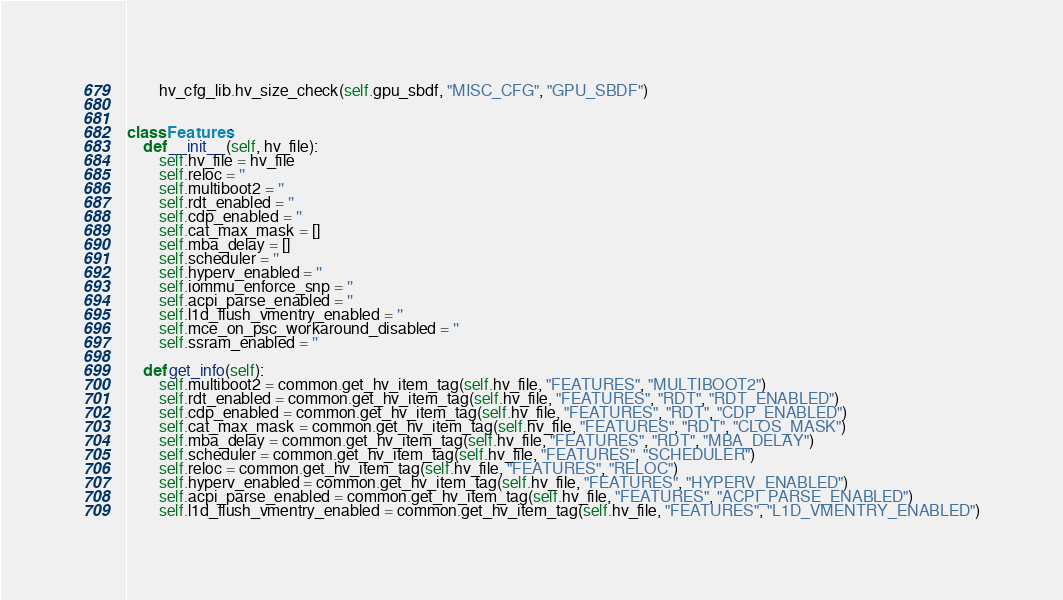Convert code to text. <code><loc_0><loc_0><loc_500><loc_500><_Python_>        hv_cfg_lib.hv_size_check(self.gpu_sbdf, "MISC_CFG", "GPU_SBDF")


class Features:
    def __init__(self, hv_file):
        self.hv_file = hv_file
        self.reloc = ''
        self.multiboot2 = ''
        self.rdt_enabled = ''
        self.cdp_enabled = ''
        self.cat_max_mask = []
        self.mba_delay = []
        self.scheduler = ''
        self.hyperv_enabled = ''
        self.iommu_enforce_snp = ''
        self.acpi_parse_enabled = ''
        self.l1d_flush_vmentry_enabled = ''
        self.mce_on_psc_workaround_disabled = ''
        self.ssram_enabled = ''

    def get_info(self):
        self.multiboot2 = common.get_hv_item_tag(self.hv_file, "FEATURES", "MULTIBOOT2")
        self.rdt_enabled = common.get_hv_item_tag(self.hv_file, "FEATURES", "RDT", "RDT_ENABLED")
        self.cdp_enabled = common.get_hv_item_tag(self.hv_file, "FEATURES", "RDT", "CDP_ENABLED")
        self.cat_max_mask = common.get_hv_item_tag(self.hv_file, "FEATURES", "RDT", "CLOS_MASK")
        self.mba_delay = common.get_hv_item_tag(self.hv_file, "FEATURES", "RDT", "MBA_DELAY")
        self.scheduler = common.get_hv_item_tag(self.hv_file, "FEATURES", "SCHEDULER")
        self.reloc = common.get_hv_item_tag(self.hv_file, "FEATURES", "RELOC")
        self.hyperv_enabled = common.get_hv_item_tag(self.hv_file, "FEATURES", "HYPERV_ENABLED")
        self.acpi_parse_enabled = common.get_hv_item_tag(self.hv_file, "FEATURES", "ACPI_PARSE_ENABLED")
        self.l1d_flush_vmentry_enabled = common.get_hv_item_tag(self.hv_file, "FEATURES", "L1D_VMENTRY_ENABLED")</code> 